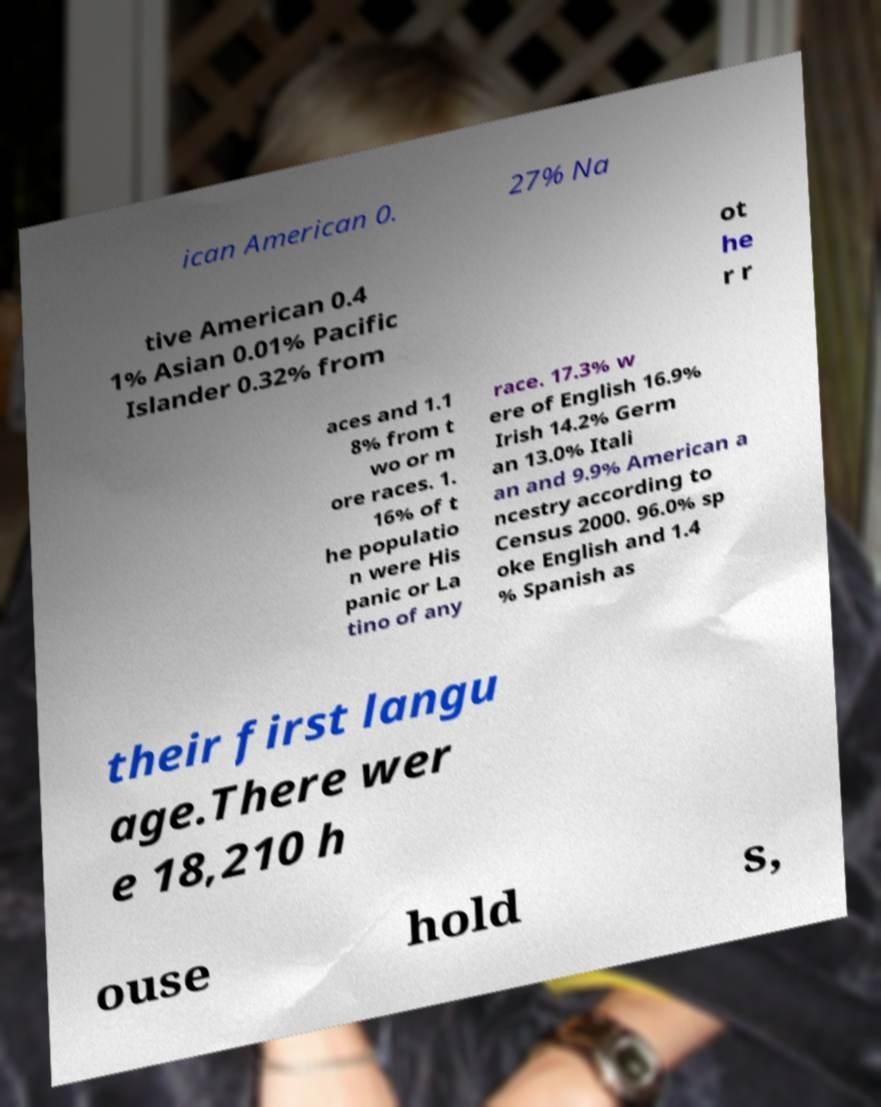Could you extract and type out the text from this image? ican American 0. 27% Na tive American 0.4 1% Asian 0.01% Pacific Islander 0.32% from ot he r r aces and 1.1 8% from t wo or m ore races. 1. 16% of t he populatio n were His panic or La tino of any race. 17.3% w ere of English 16.9% Irish 14.2% Germ an 13.0% Itali an and 9.9% American a ncestry according to Census 2000. 96.0% sp oke English and 1.4 % Spanish as their first langu age.There wer e 18,210 h ouse hold s, 